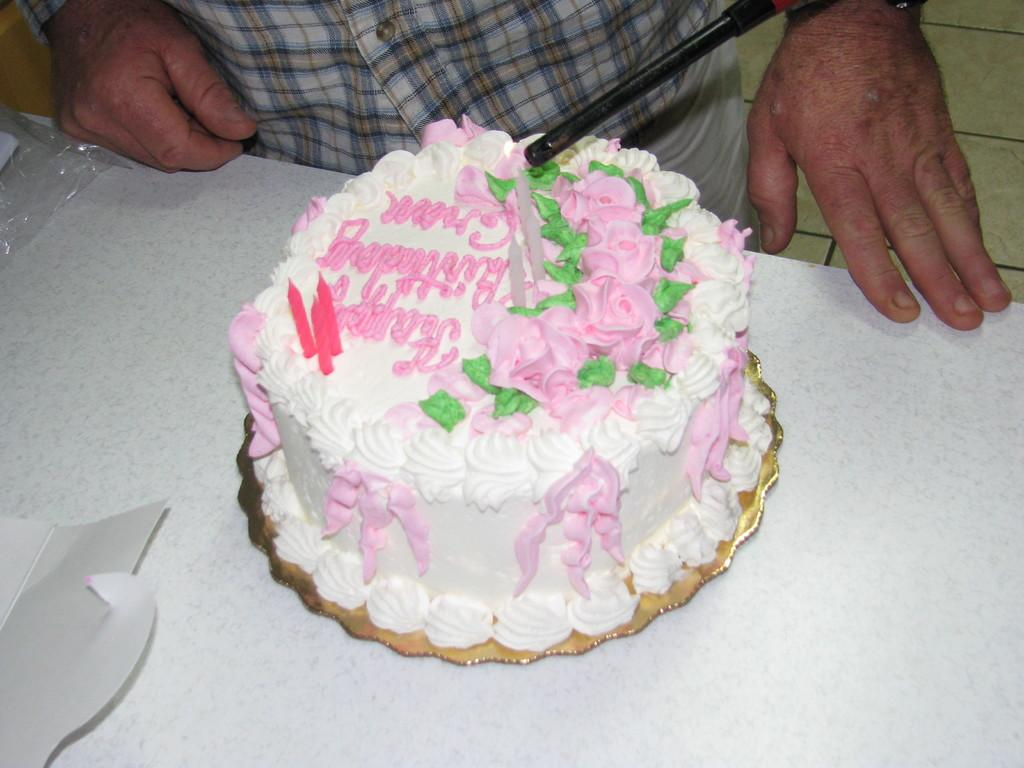What is the person in the image doing? The person is standing in front of a table. What is on the table might be the focus of attention? There is a cake on the table. How is the cake being protected or preserved? There is a cover on the cake. What might be used to celebrate a special occasion on the cake? There are candles represented on the cake. What type of soup is being served in the image? There is no soup present in the image; it features a person standing in front of a table with a covered cake. How many knots are tied in the candles on the cake? There are no knots in the candles on the cake; they are simply represented as part of the cake's decoration. 